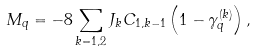<formula> <loc_0><loc_0><loc_500><loc_500>M _ { q } = - 8 \sum _ { k = 1 , 2 } J _ { k } C _ { 1 , k - 1 } \left ( 1 - \gamma _ { q } ^ { ( k ) } \right ) ,</formula> 